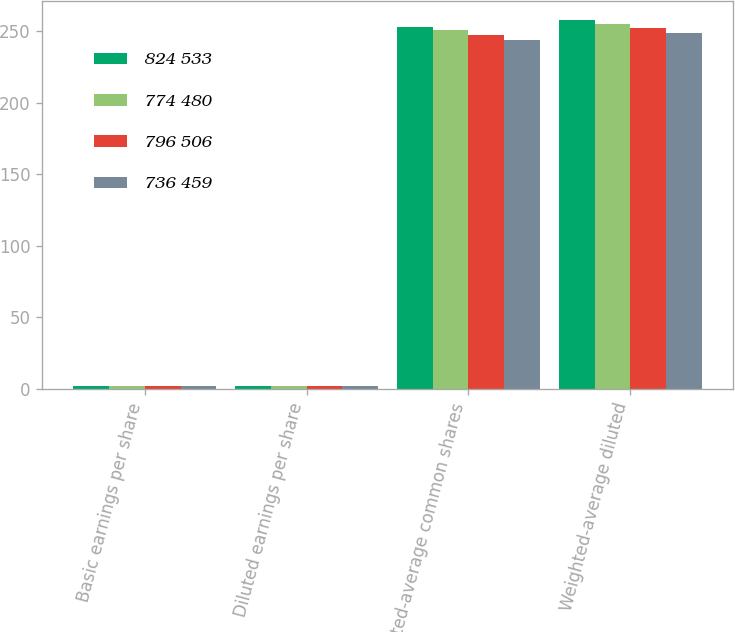Convert chart. <chart><loc_0><loc_0><loc_500><loc_500><stacked_bar_chart><ecel><fcel>Basic earnings per share<fcel>Diluted earnings per share<fcel>Weighted-average common shares<fcel>Weighted-average diluted<nl><fcel>824 533<fcel>2<fcel>1.96<fcel>253.1<fcel>258<nl><fcel>774 480<fcel>1.91<fcel>1.88<fcel>250.8<fcel>254.7<nl><fcel>796 506<fcel>1.86<fcel>1.82<fcel>247.2<fcel>252.1<nl><fcel>736 459<fcel>2.19<fcel>2.14<fcel>243.4<fcel>248.9<nl></chart> 